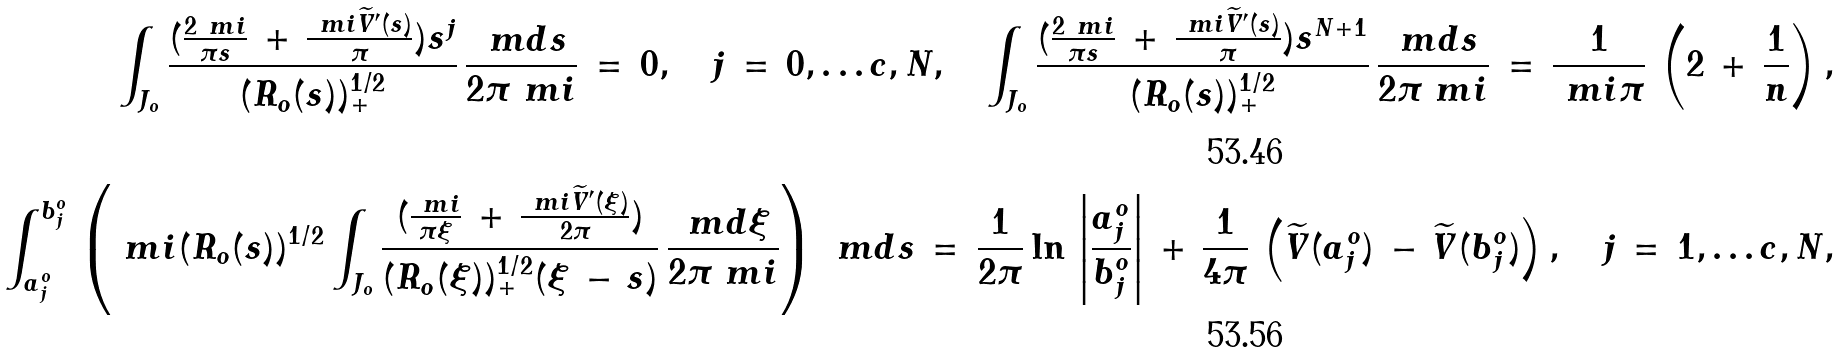Convert formula to latex. <formula><loc_0><loc_0><loc_500><loc_500>\int _ { J _ { o } } \frac { ( \frac { 2 \ m i } { \pi s } \, + \, \frac { \ m i \widetilde { V } ^ { \prime } ( s ) } { \pi } ) s ^ { j } } { ( R _ { o } ( s ) ) ^ { 1 / 2 } _ { + } } \, \frac { \ m d s } { 2 \pi \ m i } \, = \, 0 , \quad j \, = \, 0 , \dots c , N , \quad \int _ { J _ { o } } \frac { ( \frac { 2 \ m i } { \pi s } \, + \, \frac { \ m i \widetilde { V } ^ { \prime } ( s ) } { \pi } ) s ^ { N + 1 } } { ( R _ { o } ( s ) ) ^ { 1 / 2 } _ { + } } \, \frac { \ m d s } { 2 \pi \ m i } \, = \, \frac { 1 } { \ m i \pi } \, \left ( 2 \, + \, \frac { 1 } { n } \right ) , \\ \int _ { a _ { j } ^ { o } } ^ { b _ { j } ^ { o } } \, \left ( \ m i ( R _ { o } ( s ) ) ^ { 1 / 2 } \int _ { J _ { o } } \frac { ( \frac { \ m i } { \pi \xi } \, + \, \frac { \ m i \widetilde { V } ^ { \prime } ( \xi ) } { 2 \pi } ) } { ( R _ { o } ( \xi ) ) ^ { 1 / 2 } _ { + } ( \xi \, - \, s ) } \, \frac { \ m d \xi } { 2 \pi \ m i } \right ) \, \ m d s \, = \, \frac { 1 } { 2 \pi } \ln \, \left | \frac { a _ { j } ^ { o } } { b _ { j } ^ { o } } \right | \, + \, \frac { 1 } { 4 \pi } \, \left ( \widetilde { V } ( a _ { j } ^ { o } ) \, - \, \widetilde { V } ( b _ { j } ^ { o } ) \right ) , \quad j \, = \, 1 , \dots c , N ,</formula> 